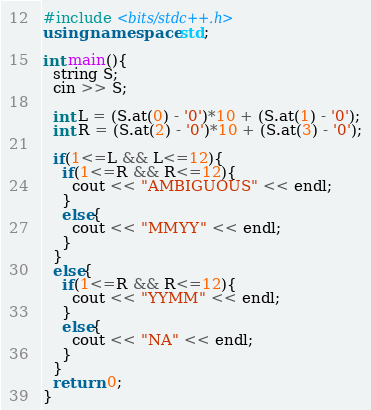<code> <loc_0><loc_0><loc_500><loc_500><_C++_>#include <bits/stdc++.h>
using namespace std;

int main(){
  string S;
  cin >> S;
  
  int L = (S.at(0) - '0')*10 + (S.at(1) - '0');
  int R = (S.at(2) - '0')*10 + (S.at(3) - '0');
  
  if(1<=L && L<=12){
    if(1<=R && R<=12){
      cout << "AMBIGUOUS" << endl;
    }
    else{
      cout << "MMYY" << endl;
    }
  }
  else{
    if(1<=R && R<=12){
      cout << "YYMM" << endl;
    }
    else{
      cout << "NA" << endl;
    }
  }
  return 0;
}</code> 